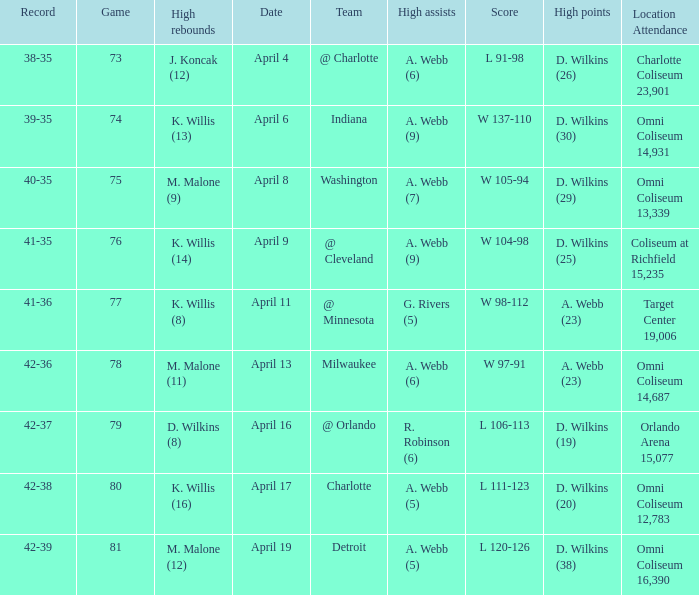Who had the high assists when the opponent was Indiana? A. Webb (9). 